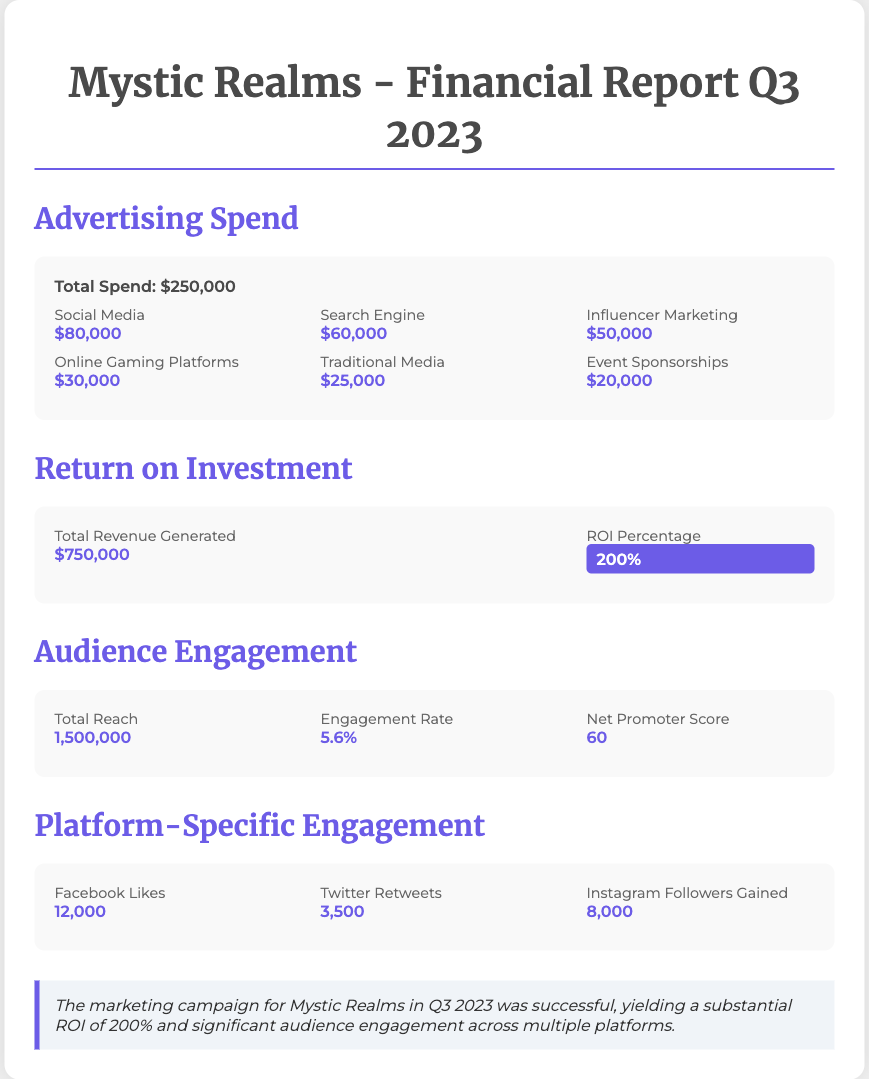What was the total advertising spend? The total advertising spend is clearly stated in the document as $250,000.
Answer: $250,000 What is the ROI percentage? The Return on Investment percentage is highlighted in the report as 200%.
Answer: 200% What is the total revenue generated? The document specifies the total revenue generated from the campaign as $750,000.
Answer: $750,000 What engagement rate was observed? The engagement rate is mentioned in the audience engagement section as 5.6%.
Answer: 5.6% How many Facebook likes were achieved? The number of Facebook likes gained during the campaign is shown as 12,000.
Answer: 12,000 What is the total reach of the campaign? The total reach of the audience is indicated as 1,500,000 in the report.
Answer: 1,500,000 Which advertising channel had the highest spend? The highest spending advertising channel is mentioned as social media with $80,000.
Answer: Social Media What was the net promoter score? The net promoter score recorded in the document is 60.
Answer: 60 What was the spend on influencer marketing? The report details that the spend on influencer marketing was $50,000.
Answer: $50,000 